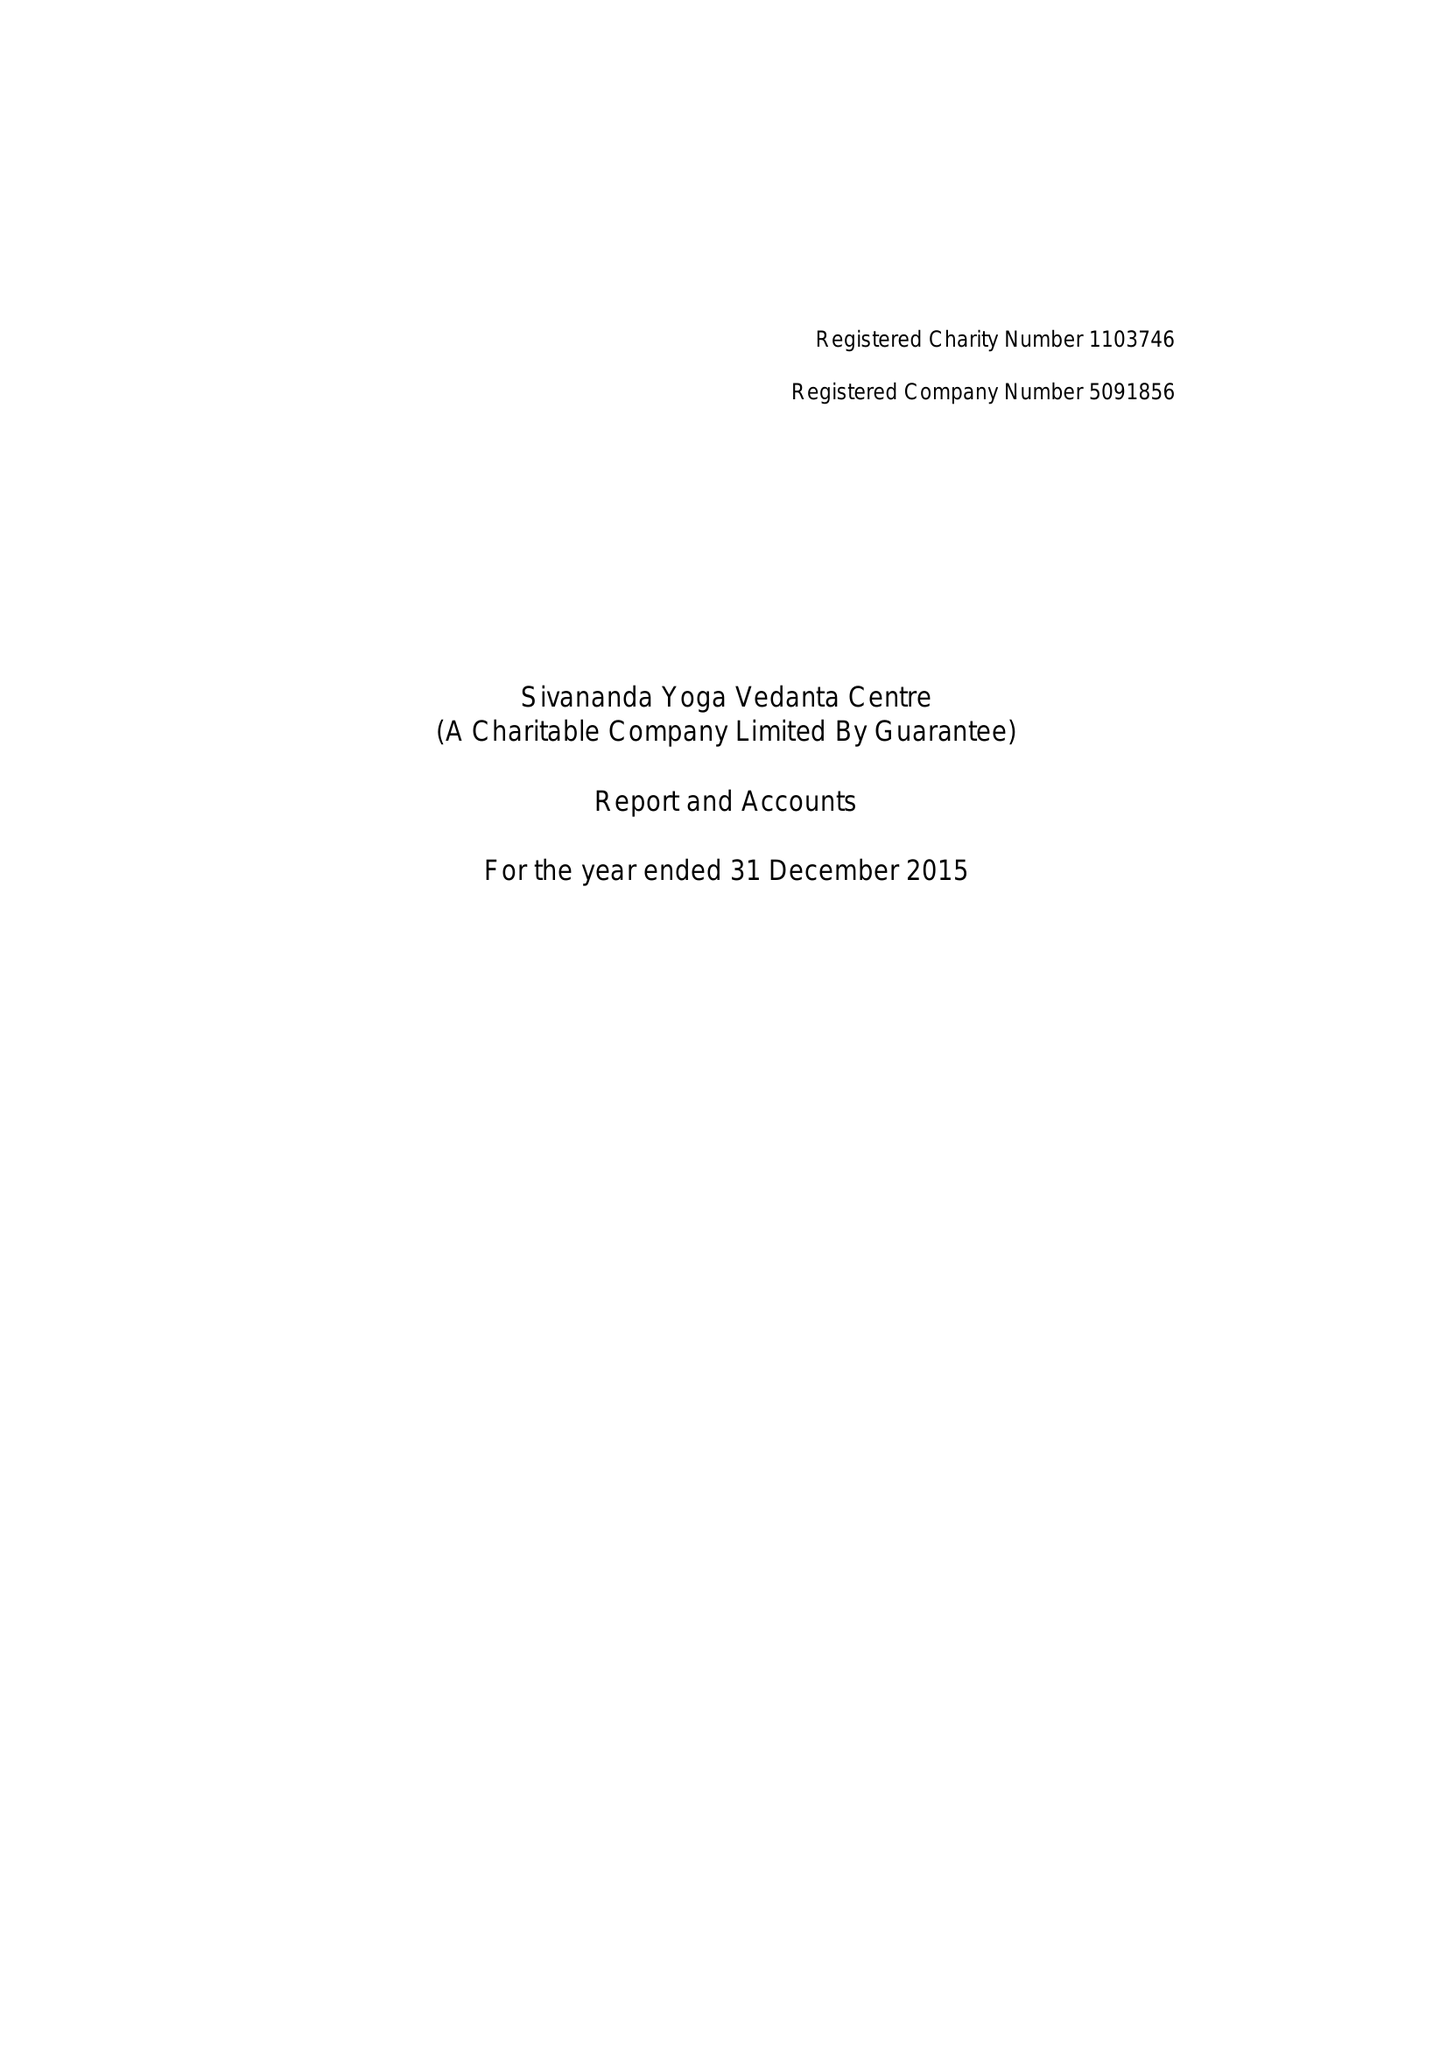What is the value for the address__post_town?
Answer the question using a single word or phrase. LONDON 